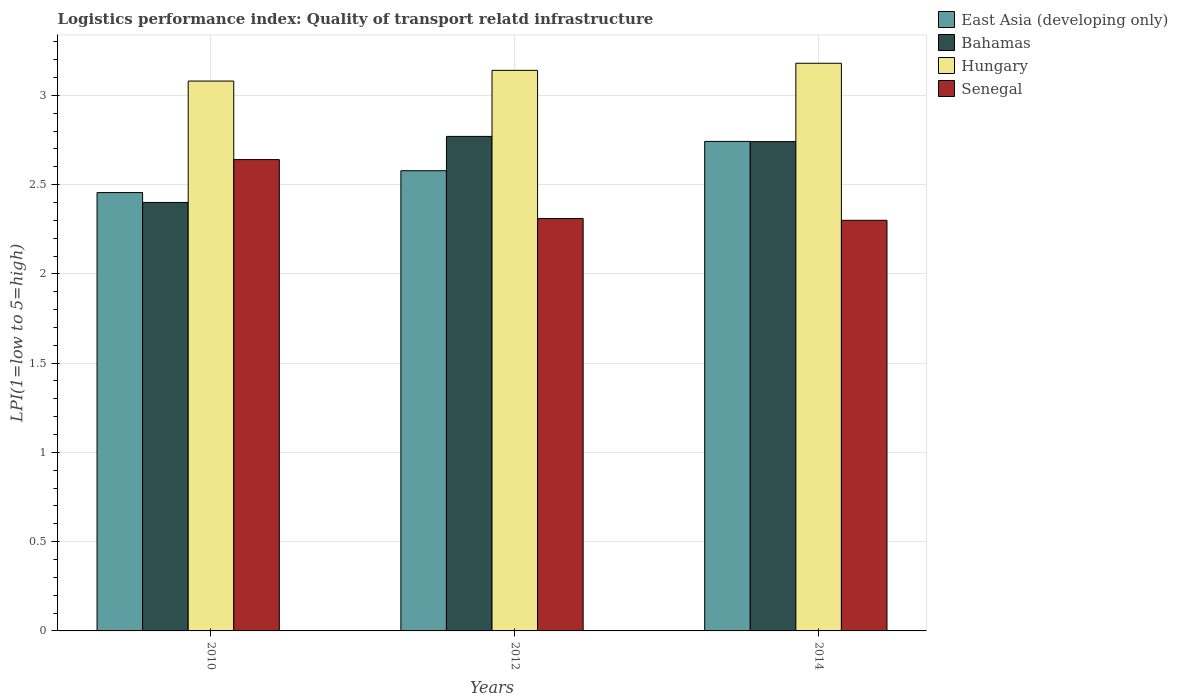How many different coloured bars are there?
Keep it short and to the point. 4. Are the number of bars per tick equal to the number of legend labels?
Your response must be concise. Yes. Are the number of bars on each tick of the X-axis equal?
Provide a short and direct response. Yes. How many bars are there on the 3rd tick from the left?
Provide a short and direct response. 4. In how many cases, is the number of bars for a given year not equal to the number of legend labels?
Keep it short and to the point. 0. What is the logistics performance index in East Asia (developing only) in 2012?
Your answer should be compact. 2.58. Across all years, what is the maximum logistics performance index in Bahamas?
Offer a very short reply. 2.77. Across all years, what is the minimum logistics performance index in Hungary?
Provide a succinct answer. 3.08. In which year was the logistics performance index in Bahamas maximum?
Offer a very short reply. 2012. What is the total logistics performance index in Hungary in the graph?
Provide a short and direct response. 9.4. What is the difference between the logistics performance index in Hungary in 2010 and that in 2014?
Your answer should be compact. -0.1. What is the difference between the logistics performance index in Bahamas in 2014 and the logistics performance index in East Asia (developing only) in 2012?
Give a very brief answer. 0.16. What is the average logistics performance index in East Asia (developing only) per year?
Provide a short and direct response. 2.59. In the year 2010, what is the difference between the logistics performance index in East Asia (developing only) and logistics performance index in Hungary?
Provide a succinct answer. -0.62. In how many years, is the logistics performance index in East Asia (developing only) greater than 1.6?
Provide a short and direct response. 3. What is the ratio of the logistics performance index in Senegal in 2012 to that in 2014?
Your response must be concise. 1. Is the difference between the logistics performance index in East Asia (developing only) in 2012 and 2014 greater than the difference between the logistics performance index in Hungary in 2012 and 2014?
Your answer should be compact. No. What is the difference between the highest and the second highest logistics performance index in Hungary?
Give a very brief answer. 0.04. What is the difference between the highest and the lowest logistics performance index in Bahamas?
Your response must be concise. 0.37. Is the sum of the logistics performance index in East Asia (developing only) in 2010 and 2012 greater than the maximum logistics performance index in Bahamas across all years?
Make the answer very short. Yes. Is it the case that in every year, the sum of the logistics performance index in Bahamas and logistics performance index in Senegal is greater than the sum of logistics performance index in Hungary and logistics performance index in East Asia (developing only)?
Provide a succinct answer. No. What does the 2nd bar from the left in 2014 represents?
Keep it short and to the point. Bahamas. What does the 1st bar from the right in 2012 represents?
Make the answer very short. Senegal. Is it the case that in every year, the sum of the logistics performance index in Senegal and logistics performance index in East Asia (developing only) is greater than the logistics performance index in Hungary?
Keep it short and to the point. Yes. What is the difference between two consecutive major ticks on the Y-axis?
Give a very brief answer. 0.5. Does the graph contain grids?
Provide a short and direct response. Yes. How many legend labels are there?
Offer a very short reply. 4. What is the title of the graph?
Provide a short and direct response. Logistics performance index: Quality of transport relatd infrastructure. Does "Georgia" appear as one of the legend labels in the graph?
Offer a very short reply. No. What is the label or title of the Y-axis?
Provide a short and direct response. LPI(1=low to 5=high). What is the LPI(1=low to 5=high) in East Asia (developing only) in 2010?
Your answer should be compact. 2.46. What is the LPI(1=low to 5=high) in Hungary in 2010?
Your answer should be very brief. 3.08. What is the LPI(1=low to 5=high) in Senegal in 2010?
Provide a short and direct response. 2.64. What is the LPI(1=low to 5=high) in East Asia (developing only) in 2012?
Your response must be concise. 2.58. What is the LPI(1=low to 5=high) in Bahamas in 2012?
Provide a succinct answer. 2.77. What is the LPI(1=low to 5=high) in Hungary in 2012?
Provide a short and direct response. 3.14. What is the LPI(1=low to 5=high) in Senegal in 2012?
Make the answer very short. 2.31. What is the LPI(1=low to 5=high) of East Asia (developing only) in 2014?
Make the answer very short. 2.74. What is the LPI(1=low to 5=high) in Bahamas in 2014?
Offer a terse response. 2.74. What is the LPI(1=low to 5=high) in Hungary in 2014?
Make the answer very short. 3.18. Across all years, what is the maximum LPI(1=low to 5=high) in East Asia (developing only)?
Make the answer very short. 2.74. Across all years, what is the maximum LPI(1=low to 5=high) in Bahamas?
Your answer should be compact. 2.77. Across all years, what is the maximum LPI(1=low to 5=high) of Hungary?
Ensure brevity in your answer.  3.18. Across all years, what is the maximum LPI(1=low to 5=high) in Senegal?
Keep it short and to the point. 2.64. Across all years, what is the minimum LPI(1=low to 5=high) of East Asia (developing only)?
Your answer should be very brief. 2.46. Across all years, what is the minimum LPI(1=low to 5=high) of Hungary?
Make the answer very short. 3.08. What is the total LPI(1=low to 5=high) of East Asia (developing only) in the graph?
Keep it short and to the point. 7.78. What is the total LPI(1=low to 5=high) in Bahamas in the graph?
Make the answer very short. 7.91. What is the total LPI(1=low to 5=high) of Hungary in the graph?
Provide a short and direct response. 9.4. What is the total LPI(1=low to 5=high) in Senegal in the graph?
Keep it short and to the point. 7.25. What is the difference between the LPI(1=low to 5=high) of East Asia (developing only) in 2010 and that in 2012?
Your response must be concise. -0.12. What is the difference between the LPI(1=low to 5=high) of Bahamas in 2010 and that in 2012?
Offer a terse response. -0.37. What is the difference between the LPI(1=low to 5=high) of Hungary in 2010 and that in 2012?
Your answer should be very brief. -0.06. What is the difference between the LPI(1=low to 5=high) in Senegal in 2010 and that in 2012?
Make the answer very short. 0.33. What is the difference between the LPI(1=low to 5=high) of East Asia (developing only) in 2010 and that in 2014?
Offer a terse response. -0.29. What is the difference between the LPI(1=low to 5=high) in Bahamas in 2010 and that in 2014?
Keep it short and to the point. -0.34. What is the difference between the LPI(1=low to 5=high) of Hungary in 2010 and that in 2014?
Provide a succinct answer. -0.1. What is the difference between the LPI(1=low to 5=high) of Senegal in 2010 and that in 2014?
Keep it short and to the point. 0.34. What is the difference between the LPI(1=low to 5=high) of East Asia (developing only) in 2012 and that in 2014?
Offer a very short reply. -0.16. What is the difference between the LPI(1=low to 5=high) of Bahamas in 2012 and that in 2014?
Your answer should be very brief. 0.03. What is the difference between the LPI(1=low to 5=high) of Hungary in 2012 and that in 2014?
Make the answer very short. -0.04. What is the difference between the LPI(1=low to 5=high) of East Asia (developing only) in 2010 and the LPI(1=low to 5=high) of Bahamas in 2012?
Ensure brevity in your answer.  -0.31. What is the difference between the LPI(1=low to 5=high) in East Asia (developing only) in 2010 and the LPI(1=low to 5=high) in Hungary in 2012?
Your answer should be very brief. -0.68. What is the difference between the LPI(1=low to 5=high) of East Asia (developing only) in 2010 and the LPI(1=low to 5=high) of Senegal in 2012?
Your response must be concise. 0.15. What is the difference between the LPI(1=low to 5=high) of Bahamas in 2010 and the LPI(1=low to 5=high) of Hungary in 2012?
Your answer should be compact. -0.74. What is the difference between the LPI(1=low to 5=high) of Bahamas in 2010 and the LPI(1=low to 5=high) of Senegal in 2012?
Provide a succinct answer. 0.09. What is the difference between the LPI(1=low to 5=high) of Hungary in 2010 and the LPI(1=low to 5=high) of Senegal in 2012?
Make the answer very short. 0.77. What is the difference between the LPI(1=low to 5=high) in East Asia (developing only) in 2010 and the LPI(1=low to 5=high) in Bahamas in 2014?
Keep it short and to the point. -0.29. What is the difference between the LPI(1=low to 5=high) in East Asia (developing only) in 2010 and the LPI(1=low to 5=high) in Hungary in 2014?
Your answer should be very brief. -0.72. What is the difference between the LPI(1=low to 5=high) of East Asia (developing only) in 2010 and the LPI(1=low to 5=high) of Senegal in 2014?
Ensure brevity in your answer.  0.16. What is the difference between the LPI(1=low to 5=high) in Bahamas in 2010 and the LPI(1=low to 5=high) in Hungary in 2014?
Provide a short and direct response. -0.78. What is the difference between the LPI(1=low to 5=high) in Bahamas in 2010 and the LPI(1=low to 5=high) in Senegal in 2014?
Provide a short and direct response. 0.1. What is the difference between the LPI(1=low to 5=high) of Hungary in 2010 and the LPI(1=low to 5=high) of Senegal in 2014?
Your answer should be very brief. 0.78. What is the difference between the LPI(1=low to 5=high) in East Asia (developing only) in 2012 and the LPI(1=low to 5=high) in Bahamas in 2014?
Ensure brevity in your answer.  -0.16. What is the difference between the LPI(1=low to 5=high) of East Asia (developing only) in 2012 and the LPI(1=low to 5=high) of Hungary in 2014?
Offer a terse response. -0.6. What is the difference between the LPI(1=low to 5=high) of East Asia (developing only) in 2012 and the LPI(1=low to 5=high) of Senegal in 2014?
Your answer should be very brief. 0.28. What is the difference between the LPI(1=low to 5=high) of Bahamas in 2012 and the LPI(1=low to 5=high) of Hungary in 2014?
Your response must be concise. -0.41. What is the difference between the LPI(1=low to 5=high) of Bahamas in 2012 and the LPI(1=low to 5=high) of Senegal in 2014?
Give a very brief answer. 0.47. What is the difference between the LPI(1=low to 5=high) of Hungary in 2012 and the LPI(1=low to 5=high) of Senegal in 2014?
Ensure brevity in your answer.  0.84. What is the average LPI(1=low to 5=high) of East Asia (developing only) per year?
Your answer should be very brief. 2.59. What is the average LPI(1=low to 5=high) in Bahamas per year?
Provide a succinct answer. 2.64. What is the average LPI(1=low to 5=high) of Hungary per year?
Provide a succinct answer. 3.13. What is the average LPI(1=low to 5=high) of Senegal per year?
Make the answer very short. 2.42. In the year 2010, what is the difference between the LPI(1=low to 5=high) in East Asia (developing only) and LPI(1=low to 5=high) in Bahamas?
Provide a short and direct response. 0.06. In the year 2010, what is the difference between the LPI(1=low to 5=high) of East Asia (developing only) and LPI(1=low to 5=high) of Hungary?
Provide a succinct answer. -0.62. In the year 2010, what is the difference between the LPI(1=low to 5=high) of East Asia (developing only) and LPI(1=low to 5=high) of Senegal?
Offer a very short reply. -0.18. In the year 2010, what is the difference between the LPI(1=low to 5=high) of Bahamas and LPI(1=low to 5=high) of Hungary?
Give a very brief answer. -0.68. In the year 2010, what is the difference between the LPI(1=low to 5=high) of Bahamas and LPI(1=low to 5=high) of Senegal?
Ensure brevity in your answer.  -0.24. In the year 2010, what is the difference between the LPI(1=low to 5=high) of Hungary and LPI(1=low to 5=high) of Senegal?
Provide a succinct answer. 0.44. In the year 2012, what is the difference between the LPI(1=low to 5=high) in East Asia (developing only) and LPI(1=low to 5=high) in Bahamas?
Your answer should be compact. -0.19. In the year 2012, what is the difference between the LPI(1=low to 5=high) of East Asia (developing only) and LPI(1=low to 5=high) of Hungary?
Your answer should be compact. -0.56. In the year 2012, what is the difference between the LPI(1=low to 5=high) of East Asia (developing only) and LPI(1=low to 5=high) of Senegal?
Offer a very short reply. 0.27. In the year 2012, what is the difference between the LPI(1=low to 5=high) in Bahamas and LPI(1=low to 5=high) in Hungary?
Your answer should be very brief. -0.37. In the year 2012, what is the difference between the LPI(1=low to 5=high) of Bahamas and LPI(1=low to 5=high) of Senegal?
Give a very brief answer. 0.46. In the year 2012, what is the difference between the LPI(1=low to 5=high) in Hungary and LPI(1=low to 5=high) in Senegal?
Keep it short and to the point. 0.83. In the year 2014, what is the difference between the LPI(1=low to 5=high) of East Asia (developing only) and LPI(1=low to 5=high) of Bahamas?
Keep it short and to the point. 0. In the year 2014, what is the difference between the LPI(1=low to 5=high) in East Asia (developing only) and LPI(1=low to 5=high) in Hungary?
Ensure brevity in your answer.  -0.44. In the year 2014, what is the difference between the LPI(1=low to 5=high) in East Asia (developing only) and LPI(1=low to 5=high) in Senegal?
Give a very brief answer. 0.44. In the year 2014, what is the difference between the LPI(1=low to 5=high) in Bahamas and LPI(1=low to 5=high) in Hungary?
Offer a terse response. -0.44. In the year 2014, what is the difference between the LPI(1=low to 5=high) of Bahamas and LPI(1=low to 5=high) of Senegal?
Your response must be concise. 0.44. In the year 2014, what is the difference between the LPI(1=low to 5=high) of Hungary and LPI(1=low to 5=high) of Senegal?
Ensure brevity in your answer.  0.88. What is the ratio of the LPI(1=low to 5=high) in East Asia (developing only) in 2010 to that in 2012?
Provide a succinct answer. 0.95. What is the ratio of the LPI(1=low to 5=high) of Bahamas in 2010 to that in 2012?
Provide a succinct answer. 0.87. What is the ratio of the LPI(1=low to 5=high) of Hungary in 2010 to that in 2012?
Your response must be concise. 0.98. What is the ratio of the LPI(1=low to 5=high) of Senegal in 2010 to that in 2012?
Keep it short and to the point. 1.14. What is the ratio of the LPI(1=low to 5=high) in East Asia (developing only) in 2010 to that in 2014?
Provide a succinct answer. 0.9. What is the ratio of the LPI(1=low to 5=high) of Bahamas in 2010 to that in 2014?
Offer a very short reply. 0.88. What is the ratio of the LPI(1=low to 5=high) in Hungary in 2010 to that in 2014?
Offer a terse response. 0.97. What is the ratio of the LPI(1=low to 5=high) in Senegal in 2010 to that in 2014?
Keep it short and to the point. 1.15. What is the ratio of the LPI(1=low to 5=high) of East Asia (developing only) in 2012 to that in 2014?
Provide a succinct answer. 0.94. What is the ratio of the LPI(1=low to 5=high) in Bahamas in 2012 to that in 2014?
Your response must be concise. 1.01. What is the ratio of the LPI(1=low to 5=high) of Hungary in 2012 to that in 2014?
Offer a very short reply. 0.99. What is the ratio of the LPI(1=low to 5=high) of Senegal in 2012 to that in 2014?
Make the answer very short. 1. What is the difference between the highest and the second highest LPI(1=low to 5=high) in East Asia (developing only)?
Provide a succinct answer. 0.16. What is the difference between the highest and the second highest LPI(1=low to 5=high) of Bahamas?
Offer a terse response. 0.03. What is the difference between the highest and the second highest LPI(1=low to 5=high) of Hungary?
Your answer should be compact. 0.04. What is the difference between the highest and the second highest LPI(1=low to 5=high) of Senegal?
Give a very brief answer. 0.33. What is the difference between the highest and the lowest LPI(1=low to 5=high) of East Asia (developing only)?
Offer a terse response. 0.29. What is the difference between the highest and the lowest LPI(1=low to 5=high) in Bahamas?
Offer a terse response. 0.37. What is the difference between the highest and the lowest LPI(1=low to 5=high) in Hungary?
Ensure brevity in your answer.  0.1. What is the difference between the highest and the lowest LPI(1=low to 5=high) in Senegal?
Your answer should be compact. 0.34. 